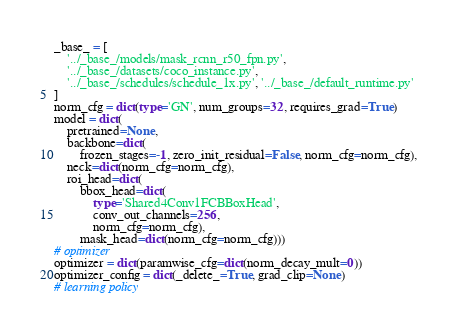Convert code to text. <code><loc_0><loc_0><loc_500><loc_500><_Python_>_base_ = [
    '../_base_/models/mask_rcnn_r50_fpn.py',
    '../_base_/datasets/coco_instance.py',
    '../_base_/schedules/schedule_1x.py', '../_base_/default_runtime.py'
]
norm_cfg = dict(type='GN', num_groups=32, requires_grad=True)
model = dict(
    pretrained=None,
    backbone=dict(
        frozen_stages=-1, zero_init_residual=False, norm_cfg=norm_cfg),
    neck=dict(norm_cfg=norm_cfg),
    roi_head=dict(
        bbox_head=dict(
            type='Shared4Conv1FCBBoxHead',
            conv_out_channels=256,
            norm_cfg=norm_cfg),
        mask_head=dict(norm_cfg=norm_cfg)))
# optimizer
optimizer = dict(paramwise_cfg=dict(norm_decay_mult=0))
optimizer_config = dict(_delete_=True, grad_clip=None)
# learning policy</code> 